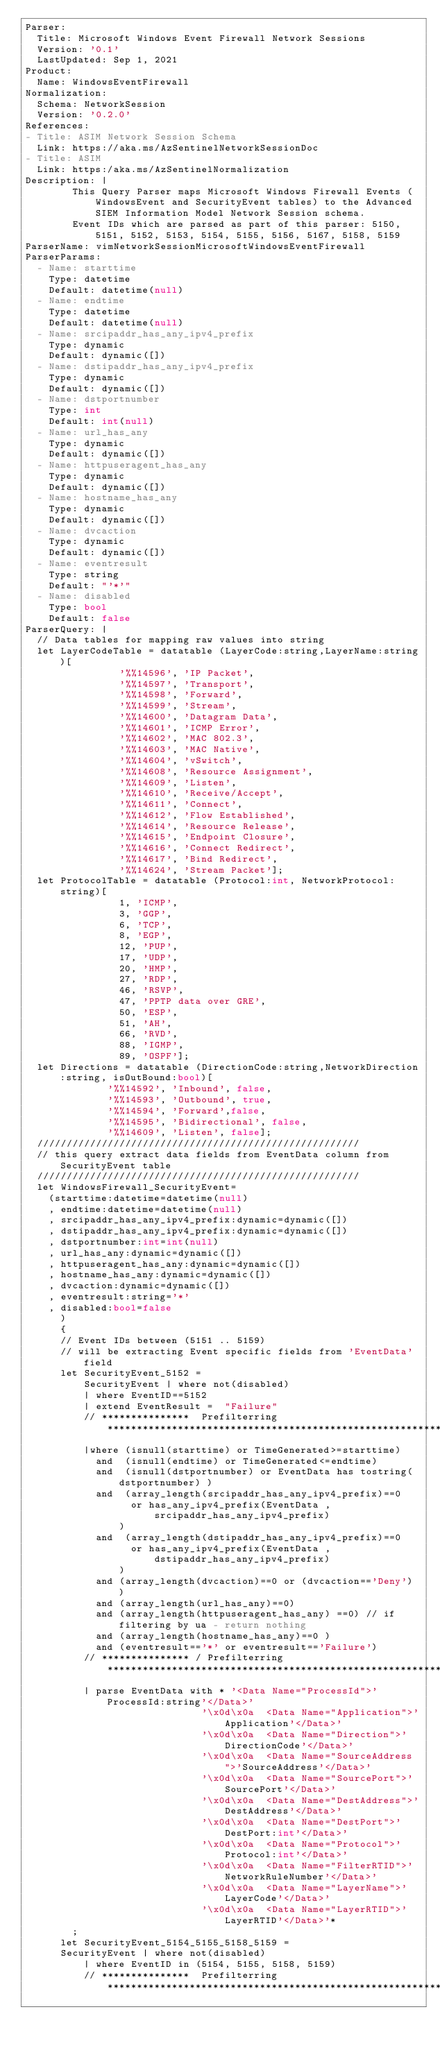Convert code to text. <code><loc_0><loc_0><loc_500><loc_500><_YAML_>Parser:
  Title: Microsoft Windows Event Firewall Network Sessions
  Version: '0.1'
  LastUpdated: Sep 1, 2021
Product:
  Name: WindowsEventFirewall
Normalization:
  Schema: NetworkSession
  Version: '0.2.0'
References:
- Title: ASIM Network Session Schema
  Link: https://aka.ms/AzSentinelNetworkSessionDoc
- Title: ASIM
  Link: https:/aka.ms/AzSentinelNormalization
Description: |
        This Query Parser maps Microsoft Windows Firewall Events (WindowsEvent and SecurityEvent tables) to the Advanced SIEM Information Model Network Session schema.
        Event IDs which are parsed as part of this parser: 5150, 5151, 5152, 5153, 5154, 5155, 5156, 5167, 5158, 5159
ParserName: vimNetworkSessionMicrosoftWindowsEventFirewall
ParserParams:
  - Name: starttime
    Type: datetime
    Default: datetime(null)
  - Name: endtime
    Type: datetime
    Default: datetime(null)
  - Name: srcipaddr_has_any_ipv4_prefix
    Type: dynamic
    Default: dynamic([])
  - Name: dstipaddr_has_any_ipv4_prefix
    Type: dynamic
    Default: dynamic([])
  - Name: dstportnumber
    Type: int
    Default: int(null)
  - Name: url_has_any
    Type: dynamic
    Default: dynamic([])
  - Name: httpuseragent_has_any
    Type: dynamic 
    Default: dynamic([])
  - Name: hostname_has_any
    Type: dynamic
    Default: dynamic([])
  - Name: dvcaction
    Type: dynamic
    Default: dynamic([])
  - Name: eventresult
    Type: string
    Default: "'*'"
  - Name: disabled
    Type: bool
    Default: false
ParserQuery: |
  // Data tables for mapping raw values into string
  let LayerCodeTable = datatable (LayerCode:string,LayerName:string)[
                '%%14596', 'IP Packet',
                '%%14597', 'Transport',
                '%%14598', 'Forward',
                '%%14599', 'Stream',
                '%%14600', 'Datagram Data',
                '%%14601', 'ICMP Error',
                '%%14602', 'MAC 802.3',
                '%%14603', 'MAC Native',
                '%%14604', 'vSwitch',
                '%%14608', 'Resource Assignment',
                '%%14609', 'Listen',
                '%%14610', 'Receive/Accept',
                '%%14611', 'Connect',
                '%%14612', 'Flow Established',
                '%%14614', 'Resource Release',
                '%%14615', 'Endpoint Closure',
                '%%14616', 'Connect Redirect',
                '%%14617', 'Bind Redirect',
                '%%14624', 'Stream Packet'];
  let ProtocolTable = datatable (Protocol:int, NetworkProtocol: string)[
                1, 'ICMP',
                3, 'GGP',
                6, 'TCP',
                8, 'EGP',
                12, 'PUP',
                17, 'UDP',
                20, 'HMP',
                27, 'RDP',
                46, 'RSVP',
                47, 'PPTP data over GRE',
                50, 'ESP',
                51, 'AH',
                66, 'RVD',
                88, 'IGMP',
                89, 'OSPF'];
  let Directions = datatable (DirectionCode:string,NetworkDirection:string, isOutBound:bool)[
              '%%14592', 'Inbound', false,
              '%%14593', 'Outbound', true,
              '%%14594', 'Forward',false,
              '%%14595', 'Bidirectional', false,
              '%%14609', 'Listen', false];
  ///////////////////////////////////////////////////////
  // this query extract data fields from EventData column from SecurityEvent table
  ///////////////////////////////////////////////////////
  let WindowsFirewall_SecurityEvent=
    (starttime:datetime=datetime(null)
    , endtime:datetime=datetime(null)
    , srcipaddr_has_any_ipv4_prefix:dynamic=dynamic([])
    , dstipaddr_has_any_ipv4_prefix:dynamic=dynamic([])
    , dstportnumber:int=int(null)
    , url_has_any:dynamic=dynamic([])
    , httpuseragent_has_any:dynamic=dynamic([])
    , hostname_has_any:dynamic=dynamic([])
    , dvcaction:dynamic=dynamic([])
    , eventresult:string='*'
    , disabled:bool=false
      )
      { 
      // Event IDs between (5151 .. 5159)
      // will be extracting Event specific fields from 'EventData' field
      let SecurityEvent_5152 = 
          SecurityEvent | where not(disabled)
          | where EventID==5152
          | extend EventResult =  "Failure"
          // ***************  Prefilterring *****************************************************************
          |where (isnull(starttime) or TimeGenerated>=starttime)
            and  (isnull(endtime) or TimeGenerated<=endtime)
            and  (isnull(dstportnumber) or EventData has tostring(dstportnumber) ) 
            and  (array_length(srcipaddr_has_any_ipv4_prefix)==0 
                  or has_any_ipv4_prefix(EventData ,srcipaddr_has_any_ipv4_prefix)
                ) 
            and  (array_length(dstipaddr_has_any_ipv4_prefix)==0 
                  or has_any_ipv4_prefix(EventData ,dstipaddr_has_any_ipv4_prefix)
                ) 
            and (array_length(dvcaction)==0 or (dvcaction=='Deny') ) 
            and (array_length(url_has_any)==0)
            and (array_length(httpuseragent_has_any) ==0) // if filtering by ua - return nothing
            and (array_length(hostname_has_any)==0 )
            and (eventresult=='*' or eventresult=='Failure')
          // *************** / Prefilterring *****************************************************************
          | parse EventData with * '<Data Name="ProcessId">'ProcessId:string'</Data>'
                              '\x0d\x0a  <Data Name="Application">'Application'</Data>'
                              '\x0d\x0a  <Data Name="Direction">'DirectionCode'</Data>'
                              '\x0d\x0a  <Data Name="SourceAddress">'SourceAddress'</Data>'
                              '\x0d\x0a  <Data Name="SourcePort">'SourcePort'</Data>'
                              '\x0d\x0a  <Data Name="DestAddress">'DestAddress'</Data>'
                              '\x0d\x0a  <Data Name="DestPort">'DestPort:int'</Data>'
                              '\x0d\x0a  <Data Name="Protocol">'Protocol:int'</Data>'
                              '\x0d\x0a  <Data Name="FilterRTID">'NetworkRuleNumber'</Data>'
                              '\x0d\x0a  <Data Name="LayerName">'LayerCode'</Data>'
                              '\x0d\x0a  <Data Name="LayerRTID">'LayerRTID'</Data>'*
        ;
      let SecurityEvent_5154_5155_5158_5159 =
      SecurityEvent | where not(disabled)
          | where EventID in (5154, 5155, 5158, 5159)
          // ***************  Prefilterring *****************************************************************</code> 